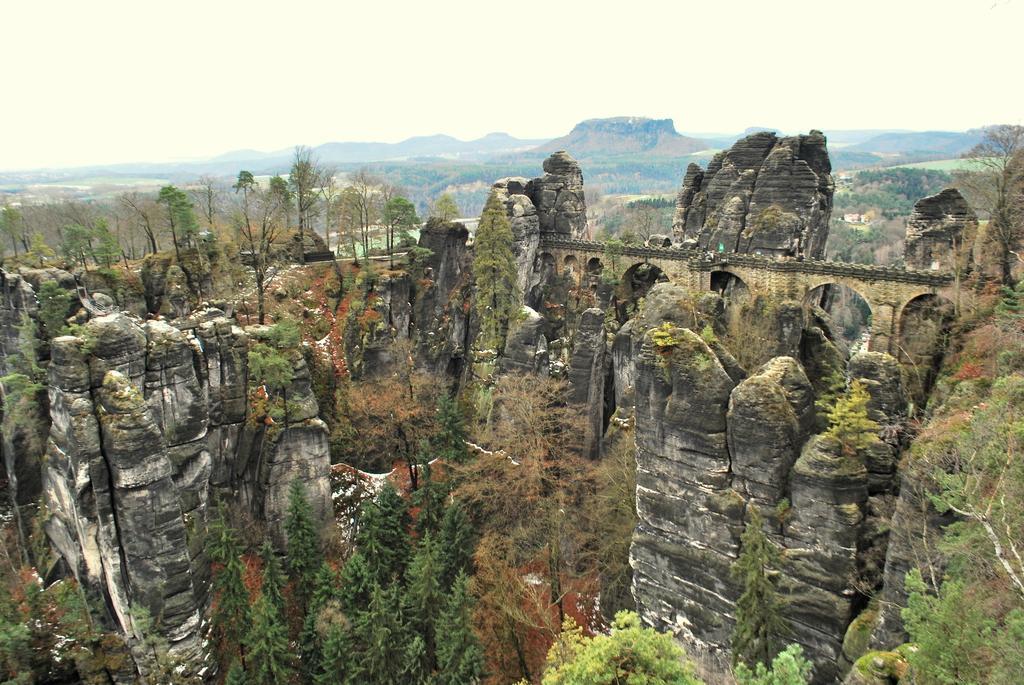Can you describe this image briefly? This is a top view of an image where we can see the rocks, trees, bridge, hills and the sky in the background. 